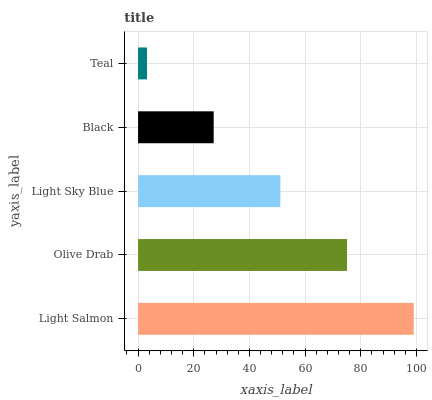Is Teal the minimum?
Answer yes or no. Yes. Is Light Salmon the maximum?
Answer yes or no. Yes. Is Olive Drab the minimum?
Answer yes or no. No. Is Olive Drab the maximum?
Answer yes or no. No. Is Light Salmon greater than Olive Drab?
Answer yes or no. Yes. Is Olive Drab less than Light Salmon?
Answer yes or no. Yes. Is Olive Drab greater than Light Salmon?
Answer yes or no. No. Is Light Salmon less than Olive Drab?
Answer yes or no. No. Is Light Sky Blue the high median?
Answer yes or no. Yes. Is Light Sky Blue the low median?
Answer yes or no. Yes. Is Teal the high median?
Answer yes or no. No. Is Olive Drab the low median?
Answer yes or no. No. 